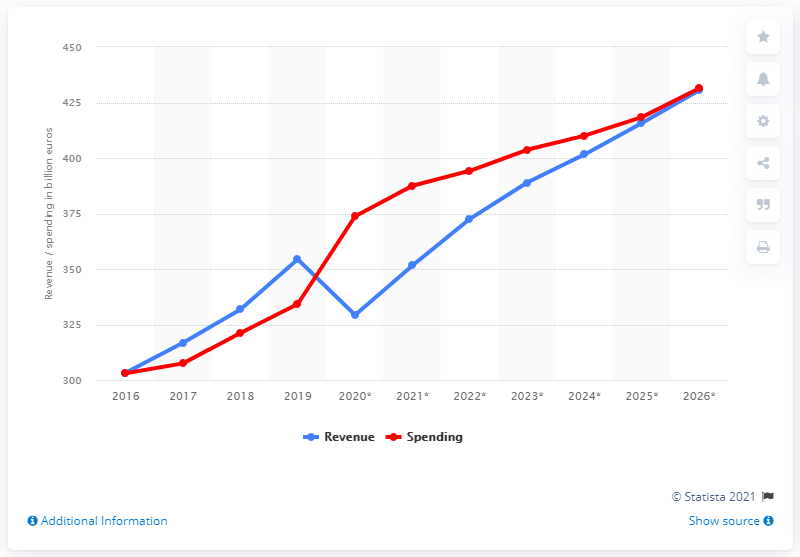Point out several critical features in this image. The government expenditure in the Netherlands in the year 2019 was 334.23. The government revenue in the Netherlands during 2019 was 351.6 billion. 